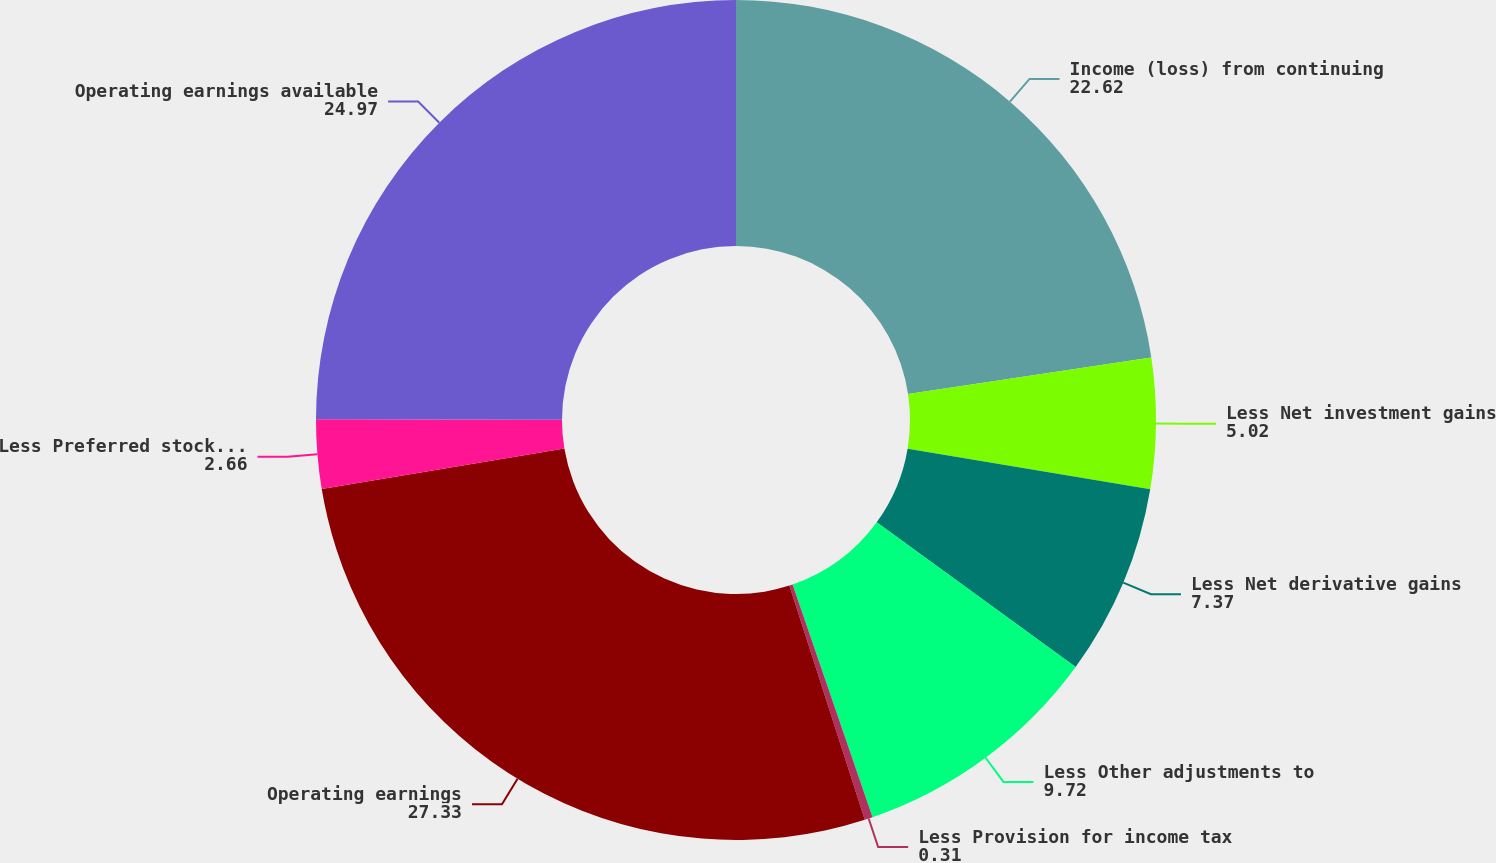<chart> <loc_0><loc_0><loc_500><loc_500><pie_chart><fcel>Income (loss) from continuing<fcel>Less Net investment gains<fcel>Less Net derivative gains<fcel>Less Other adjustments to<fcel>Less Provision for income tax<fcel>Operating earnings<fcel>Less Preferred stock dividends<fcel>Operating earnings available<nl><fcel>22.62%<fcel>5.02%<fcel>7.37%<fcel>9.72%<fcel>0.31%<fcel>27.33%<fcel>2.66%<fcel>24.97%<nl></chart> 